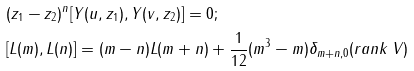Convert formula to latex. <formula><loc_0><loc_0><loc_500><loc_500>& ( z _ { 1 } - z _ { 2 } ) ^ { n } [ Y ( u , z _ { 1 } ) , Y ( v , z _ { 2 } ) ] = 0 ; \\ & [ L ( m ) , L ( n ) ] = ( m - n ) L ( m + n ) + \frac { 1 } { 1 2 } ( m ^ { 3 } - m ) \delta _ { m + n , 0 } ( r a n k \, V )</formula> 